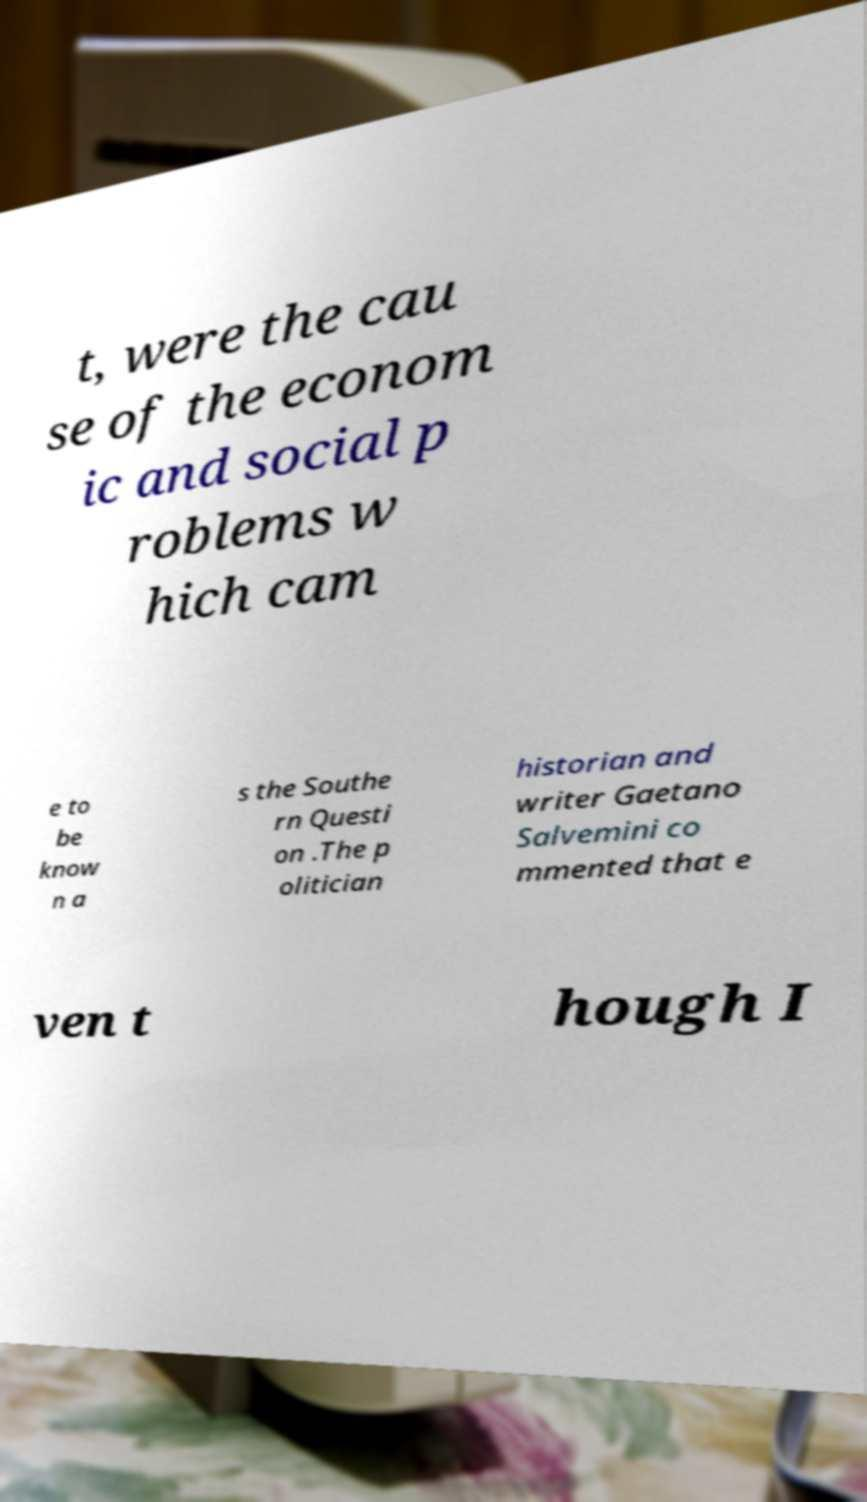For documentation purposes, I need the text within this image transcribed. Could you provide that? t, were the cau se of the econom ic and social p roblems w hich cam e to be know n a s the Southe rn Questi on .The p olitician historian and writer Gaetano Salvemini co mmented that e ven t hough I 